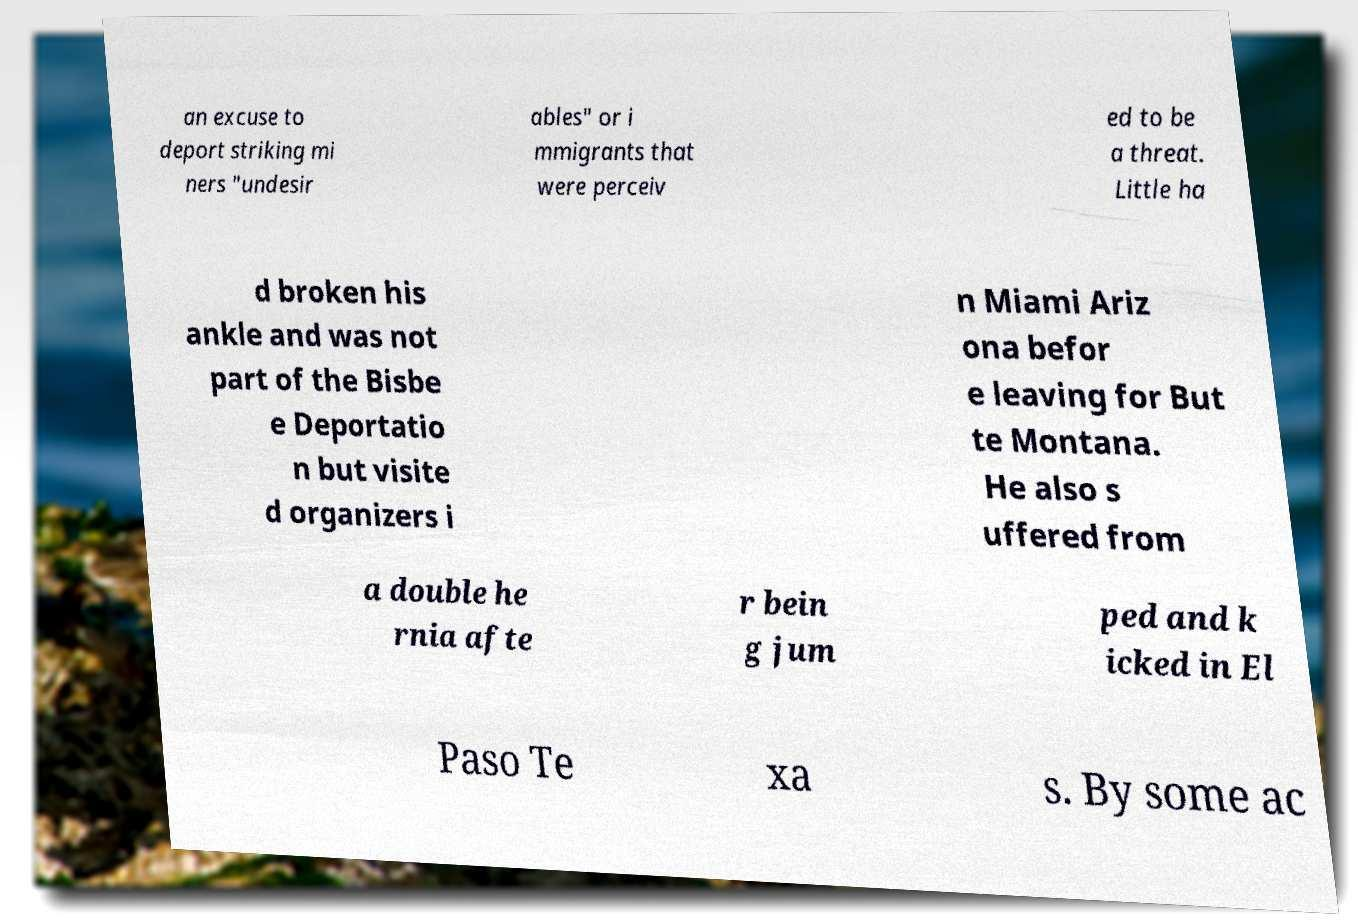Please identify and transcribe the text found in this image. an excuse to deport striking mi ners "undesir ables" or i mmigrants that were perceiv ed to be a threat. Little ha d broken his ankle and was not part of the Bisbe e Deportatio n but visite d organizers i n Miami Ariz ona befor e leaving for But te Montana. He also s uffered from a double he rnia afte r bein g jum ped and k icked in El Paso Te xa s. By some ac 